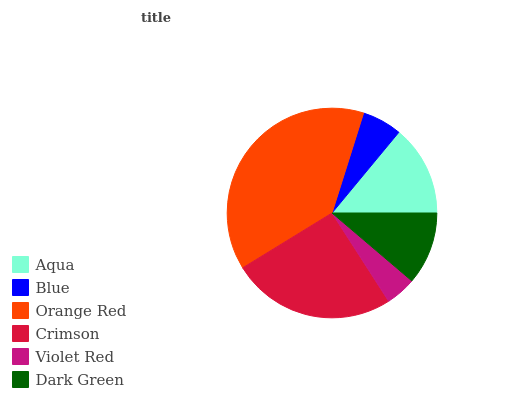Is Violet Red the minimum?
Answer yes or no. Yes. Is Orange Red the maximum?
Answer yes or no. Yes. Is Blue the minimum?
Answer yes or no. No. Is Blue the maximum?
Answer yes or no. No. Is Aqua greater than Blue?
Answer yes or no. Yes. Is Blue less than Aqua?
Answer yes or no. Yes. Is Blue greater than Aqua?
Answer yes or no. No. Is Aqua less than Blue?
Answer yes or no. No. Is Aqua the high median?
Answer yes or no. Yes. Is Dark Green the low median?
Answer yes or no. Yes. Is Crimson the high median?
Answer yes or no. No. Is Aqua the low median?
Answer yes or no. No. 